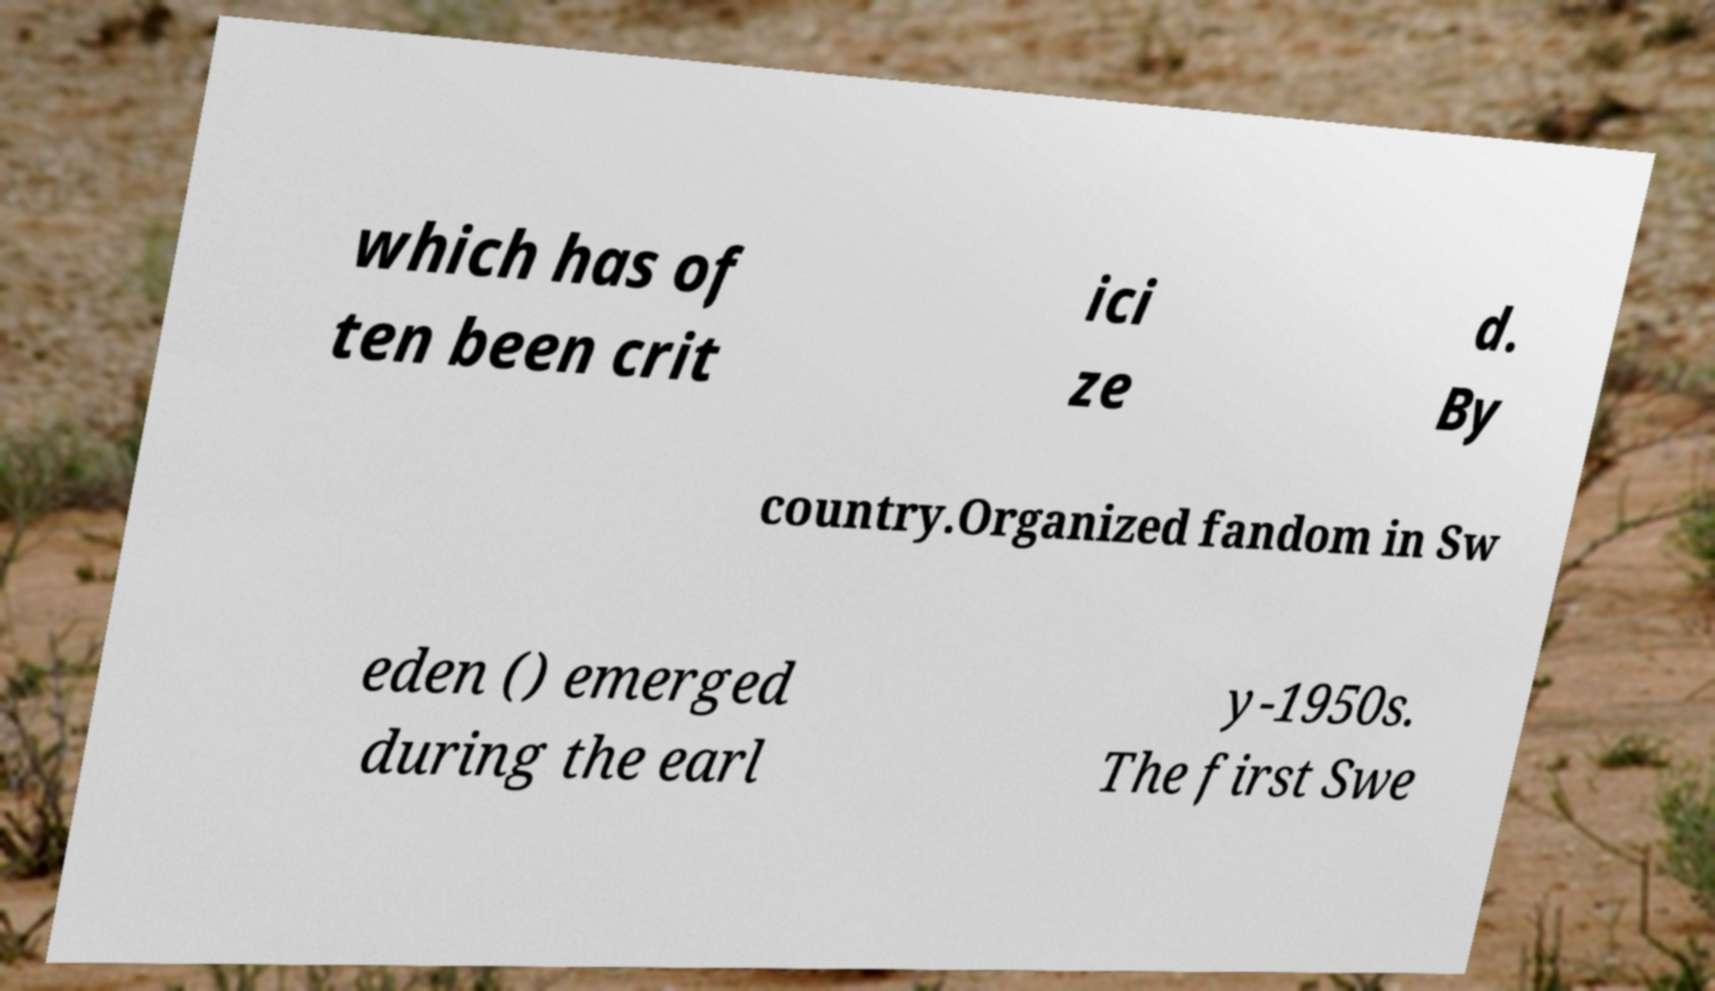Could you extract and type out the text from this image? which has of ten been crit ici ze d. By country.Organized fandom in Sw eden () emerged during the earl y-1950s. The first Swe 